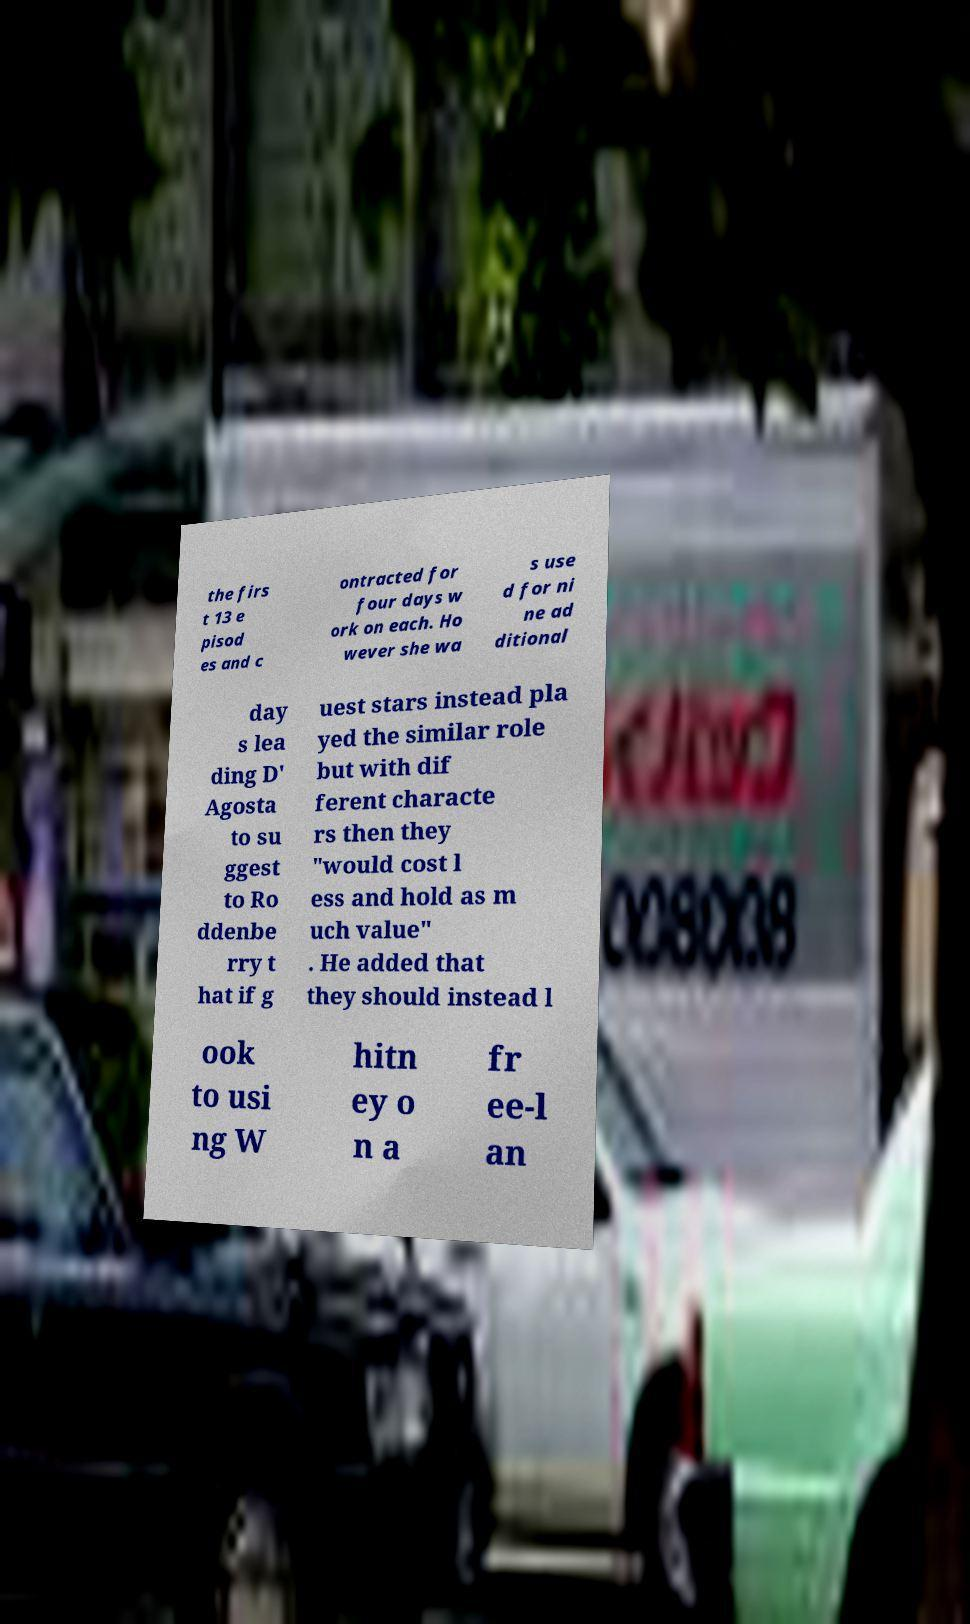Please read and relay the text visible in this image. What does it say? the firs t 13 e pisod es and c ontracted for four days w ork on each. Ho wever she wa s use d for ni ne ad ditional day s lea ding D' Agosta to su ggest to Ro ddenbe rry t hat if g uest stars instead pla yed the similar role but with dif ferent characte rs then they "would cost l ess and hold as m uch value" . He added that they should instead l ook to usi ng W hitn ey o n a fr ee-l an 